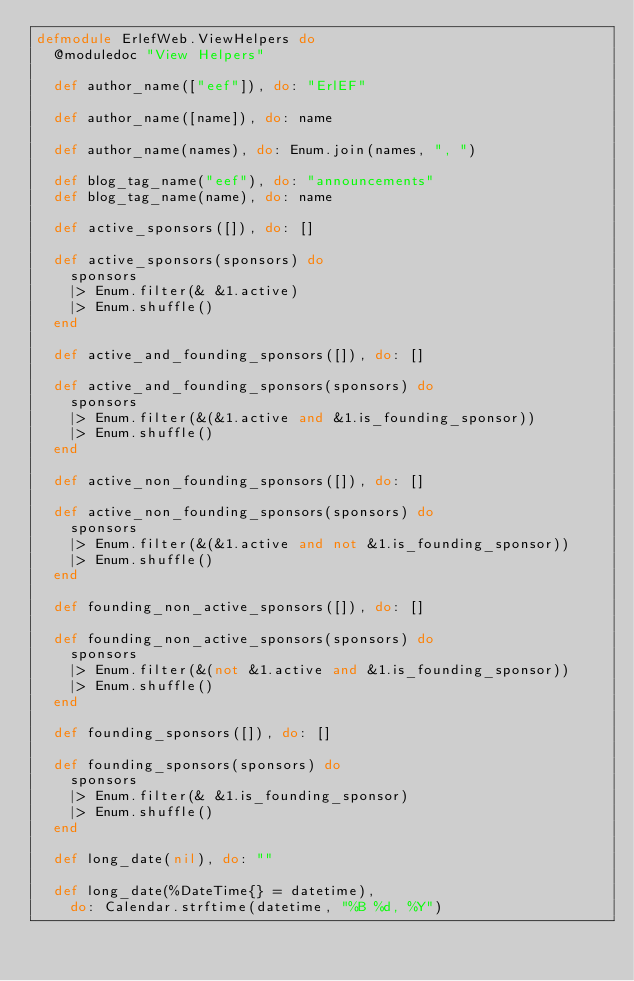<code> <loc_0><loc_0><loc_500><loc_500><_Elixir_>defmodule ErlefWeb.ViewHelpers do
  @moduledoc "View Helpers"

  def author_name(["eef"]), do: "ErlEF"

  def author_name([name]), do: name

  def author_name(names), do: Enum.join(names, ", ")

  def blog_tag_name("eef"), do: "announcements"
  def blog_tag_name(name), do: name

  def active_sponsors([]), do: []

  def active_sponsors(sponsors) do
    sponsors
    |> Enum.filter(& &1.active)
    |> Enum.shuffle()
  end

  def active_and_founding_sponsors([]), do: []

  def active_and_founding_sponsors(sponsors) do
    sponsors
    |> Enum.filter(&(&1.active and &1.is_founding_sponsor))
    |> Enum.shuffle()
  end

  def active_non_founding_sponsors([]), do: []

  def active_non_founding_sponsors(sponsors) do
    sponsors
    |> Enum.filter(&(&1.active and not &1.is_founding_sponsor))
    |> Enum.shuffle()
  end

  def founding_non_active_sponsors([]), do: []

  def founding_non_active_sponsors(sponsors) do
    sponsors
    |> Enum.filter(&(not &1.active and &1.is_founding_sponsor))
    |> Enum.shuffle()
  end

  def founding_sponsors([]), do: []

  def founding_sponsors(sponsors) do
    sponsors
    |> Enum.filter(& &1.is_founding_sponsor)
    |> Enum.shuffle()
  end

  def long_date(nil), do: ""

  def long_date(%DateTime{} = datetime),
    do: Calendar.strftime(datetime, "%B %d, %Y")
</code> 